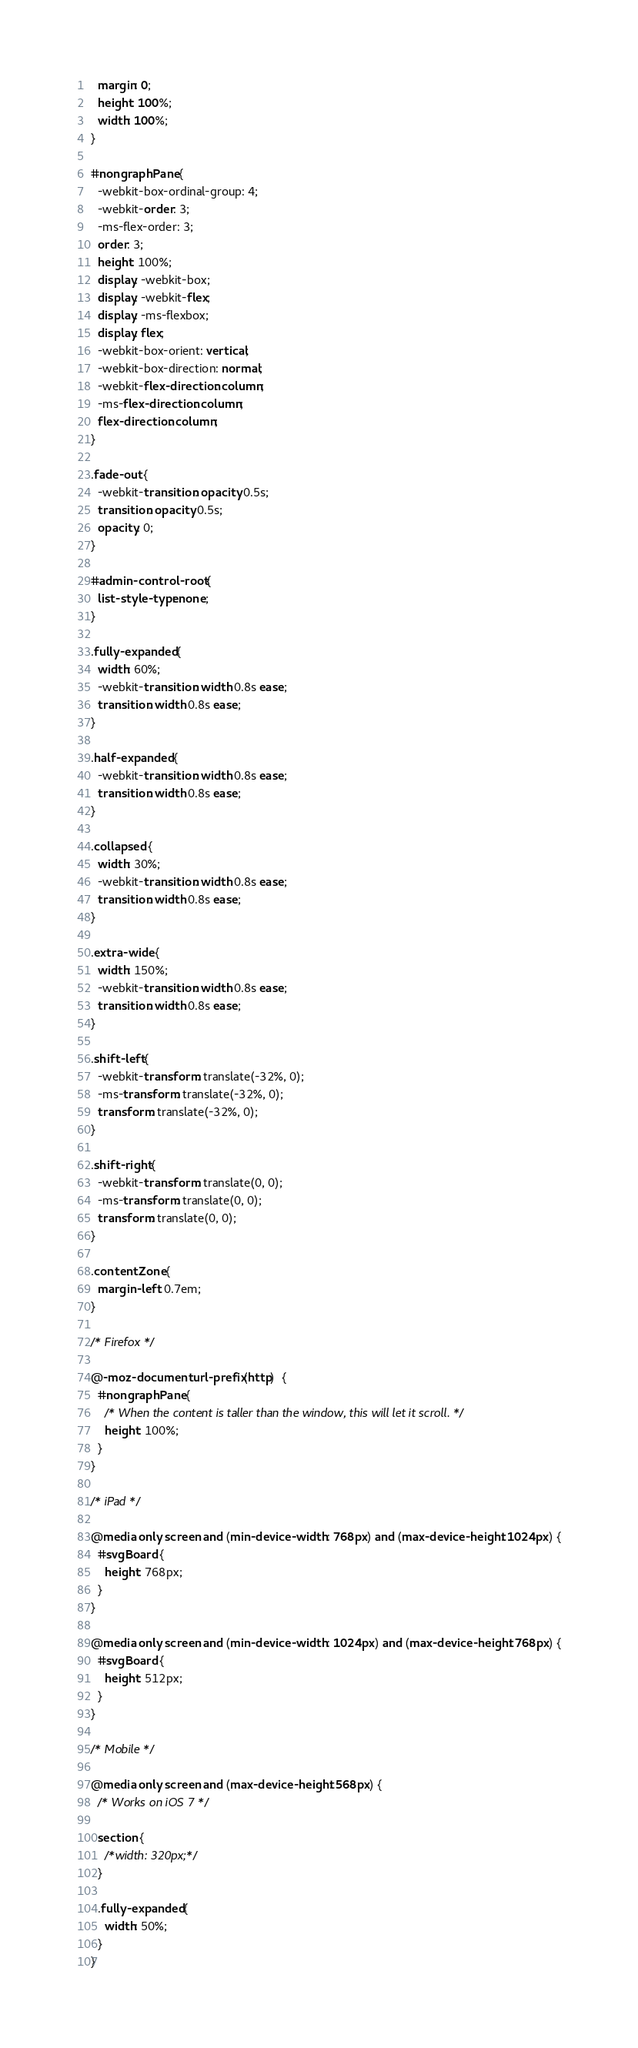<code> <loc_0><loc_0><loc_500><loc_500><_CSS_>  margin: 0;
  height: 100%;
  width: 100%;
}

#nongraphPane {
  -webkit-box-ordinal-group: 4;
  -webkit-order: 3;
  -ms-flex-order: 3;
  order: 3;
  height: 100%;
  display: -webkit-box;
  display: -webkit-flex;
  display: -ms-flexbox;
  display: flex;
  -webkit-box-orient: vertical;
  -webkit-box-direction: normal;
  -webkit-flex-direction: column;
  -ms-flex-direction: column;
  flex-direction: column;
}

.fade-out {
  -webkit-transition: opacity 0.5s;
  transition: opacity 0.5s;
  opacity: 0;
}

#admin-control-root {
  list-style-type: none;
}

.fully-expanded {
  width: 60%;
  -webkit-transition: width 0.8s ease;
  transition: width 0.8s ease;
}

.half-expanded {
  -webkit-transition: width 0.8s ease;
  transition: width 0.8s ease;
}

.collapsed {
  width: 30%;
  -webkit-transition: width 0.8s ease;
  transition: width 0.8s ease;
}

.extra-wide {
  width: 150%;
  -webkit-transition: width 0.8s ease;
  transition: width 0.8s ease;
}

.shift-left {
  -webkit-transform: translate(-32%, 0);
  -ms-transform: translate(-32%, 0);
  transform: translate(-32%, 0);
}

.shift-right {
  -webkit-transform: translate(0, 0);
  -ms-transform: translate(0, 0);
  transform: translate(0, 0);
}

.contentZone {
  margin-left: 0.7em;
}

/* Firefox */

@-moz-document url-prefix(http)  {
  #nongraphPane {
    /* When the content is taller than the window, this will let it scroll. */
    height: 100%;
  }
}

/* iPad */

@media only screen and (min-device-width : 768px) and (max-device-height: 1024px) {
  #svgBoard {
    height: 768px;
  }
}

@media only screen and (min-device-width : 1024px) and (max-device-height: 768px) {
  #svgBoard {
    height: 512px;
  }
}

/* Mobile */

@media only screen and (max-device-height: 568px) {
  /* Works on iOS 7 */

  section {
    /*width: 320px;*/
  }

  .fully-expanded {
    width: 50%;
  }
}</code> 